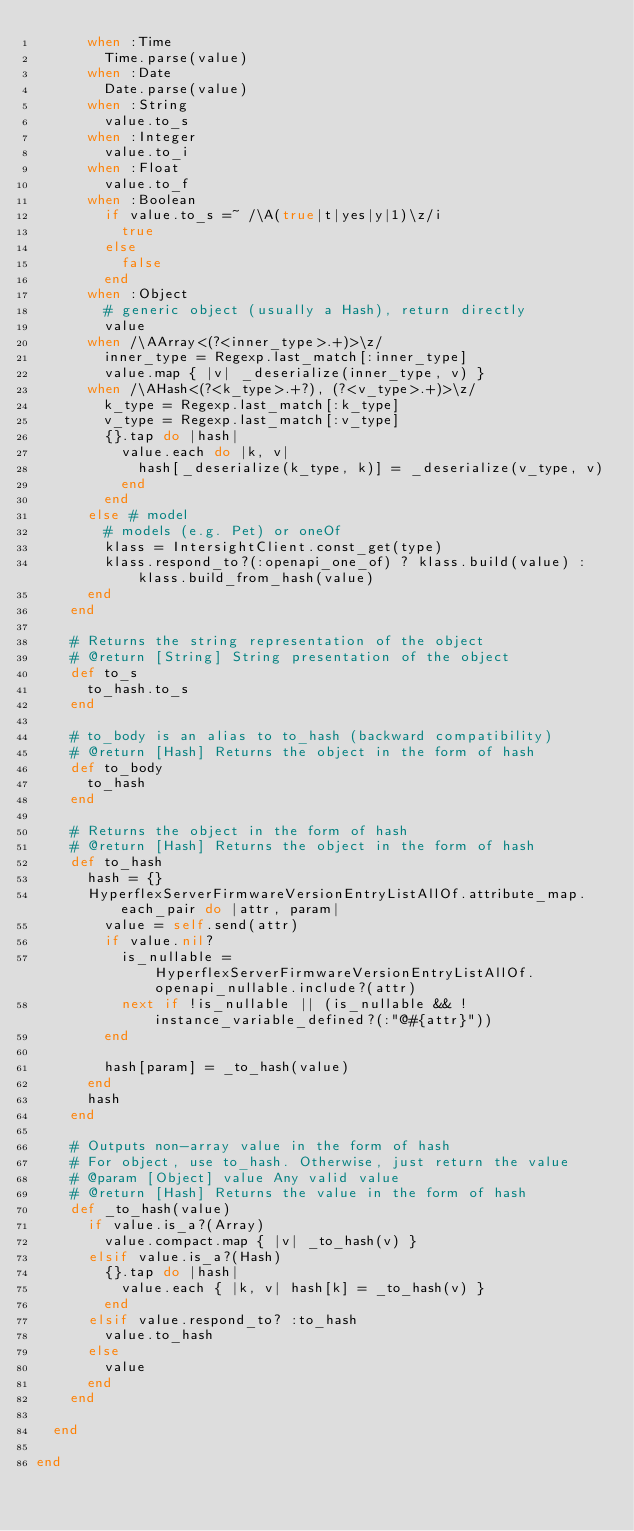<code> <loc_0><loc_0><loc_500><loc_500><_Ruby_>      when :Time
        Time.parse(value)
      when :Date
        Date.parse(value)
      when :String
        value.to_s
      when :Integer
        value.to_i
      when :Float
        value.to_f
      when :Boolean
        if value.to_s =~ /\A(true|t|yes|y|1)\z/i
          true
        else
          false
        end
      when :Object
        # generic object (usually a Hash), return directly
        value
      when /\AArray<(?<inner_type>.+)>\z/
        inner_type = Regexp.last_match[:inner_type]
        value.map { |v| _deserialize(inner_type, v) }
      when /\AHash<(?<k_type>.+?), (?<v_type>.+)>\z/
        k_type = Regexp.last_match[:k_type]
        v_type = Regexp.last_match[:v_type]
        {}.tap do |hash|
          value.each do |k, v|
            hash[_deserialize(k_type, k)] = _deserialize(v_type, v)
          end
        end
      else # model
        # models (e.g. Pet) or oneOf
        klass = IntersightClient.const_get(type)
        klass.respond_to?(:openapi_one_of) ? klass.build(value) : klass.build_from_hash(value)
      end
    end

    # Returns the string representation of the object
    # @return [String] String presentation of the object
    def to_s
      to_hash.to_s
    end

    # to_body is an alias to to_hash (backward compatibility)
    # @return [Hash] Returns the object in the form of hash
    def to_body
      to_hash
    end

    # Returns the object in the form of hash
    # @return [Hash] Returns the object in the form of hash
    def to_hash
      hash = {}
      HyperflexServerFirmwareVersionEntryListAllOf.attribute_map.each_pair do |attr, param|
        value = self.send(attr)
        if value.nil?
          is_nullable = HyperflexServerFirmwareVersionEntryListAllOf.openapi_nullable.include?(attr)
          next if !is_nullable || (is_nullable && !instance_variable_defined?(:"@#{attr}"))
        end

        hash[param] = _to_hash(value)
      end
      hash
    end

    # Outputs non-array value in the form of hash
    # For object, use to_hash. Otherwise, just return the value
    # @param [Object] value Any valid value
    # @return [Hash] Returns the value in the form of hash
    def _to_hash(value)
      if value.is_a?(Array)
        value.compact.map { |v| _to_hash(v) }
      elsif value.is_a?(Hash)
        {}.tap do |hash|
          value.each { |k, v| hash[k] = _to_hash(v) }
        end
      elsif value.respond_to? :to_hash
        value.to_hash
      else
        value
      end
    end

  end

end
</code> 